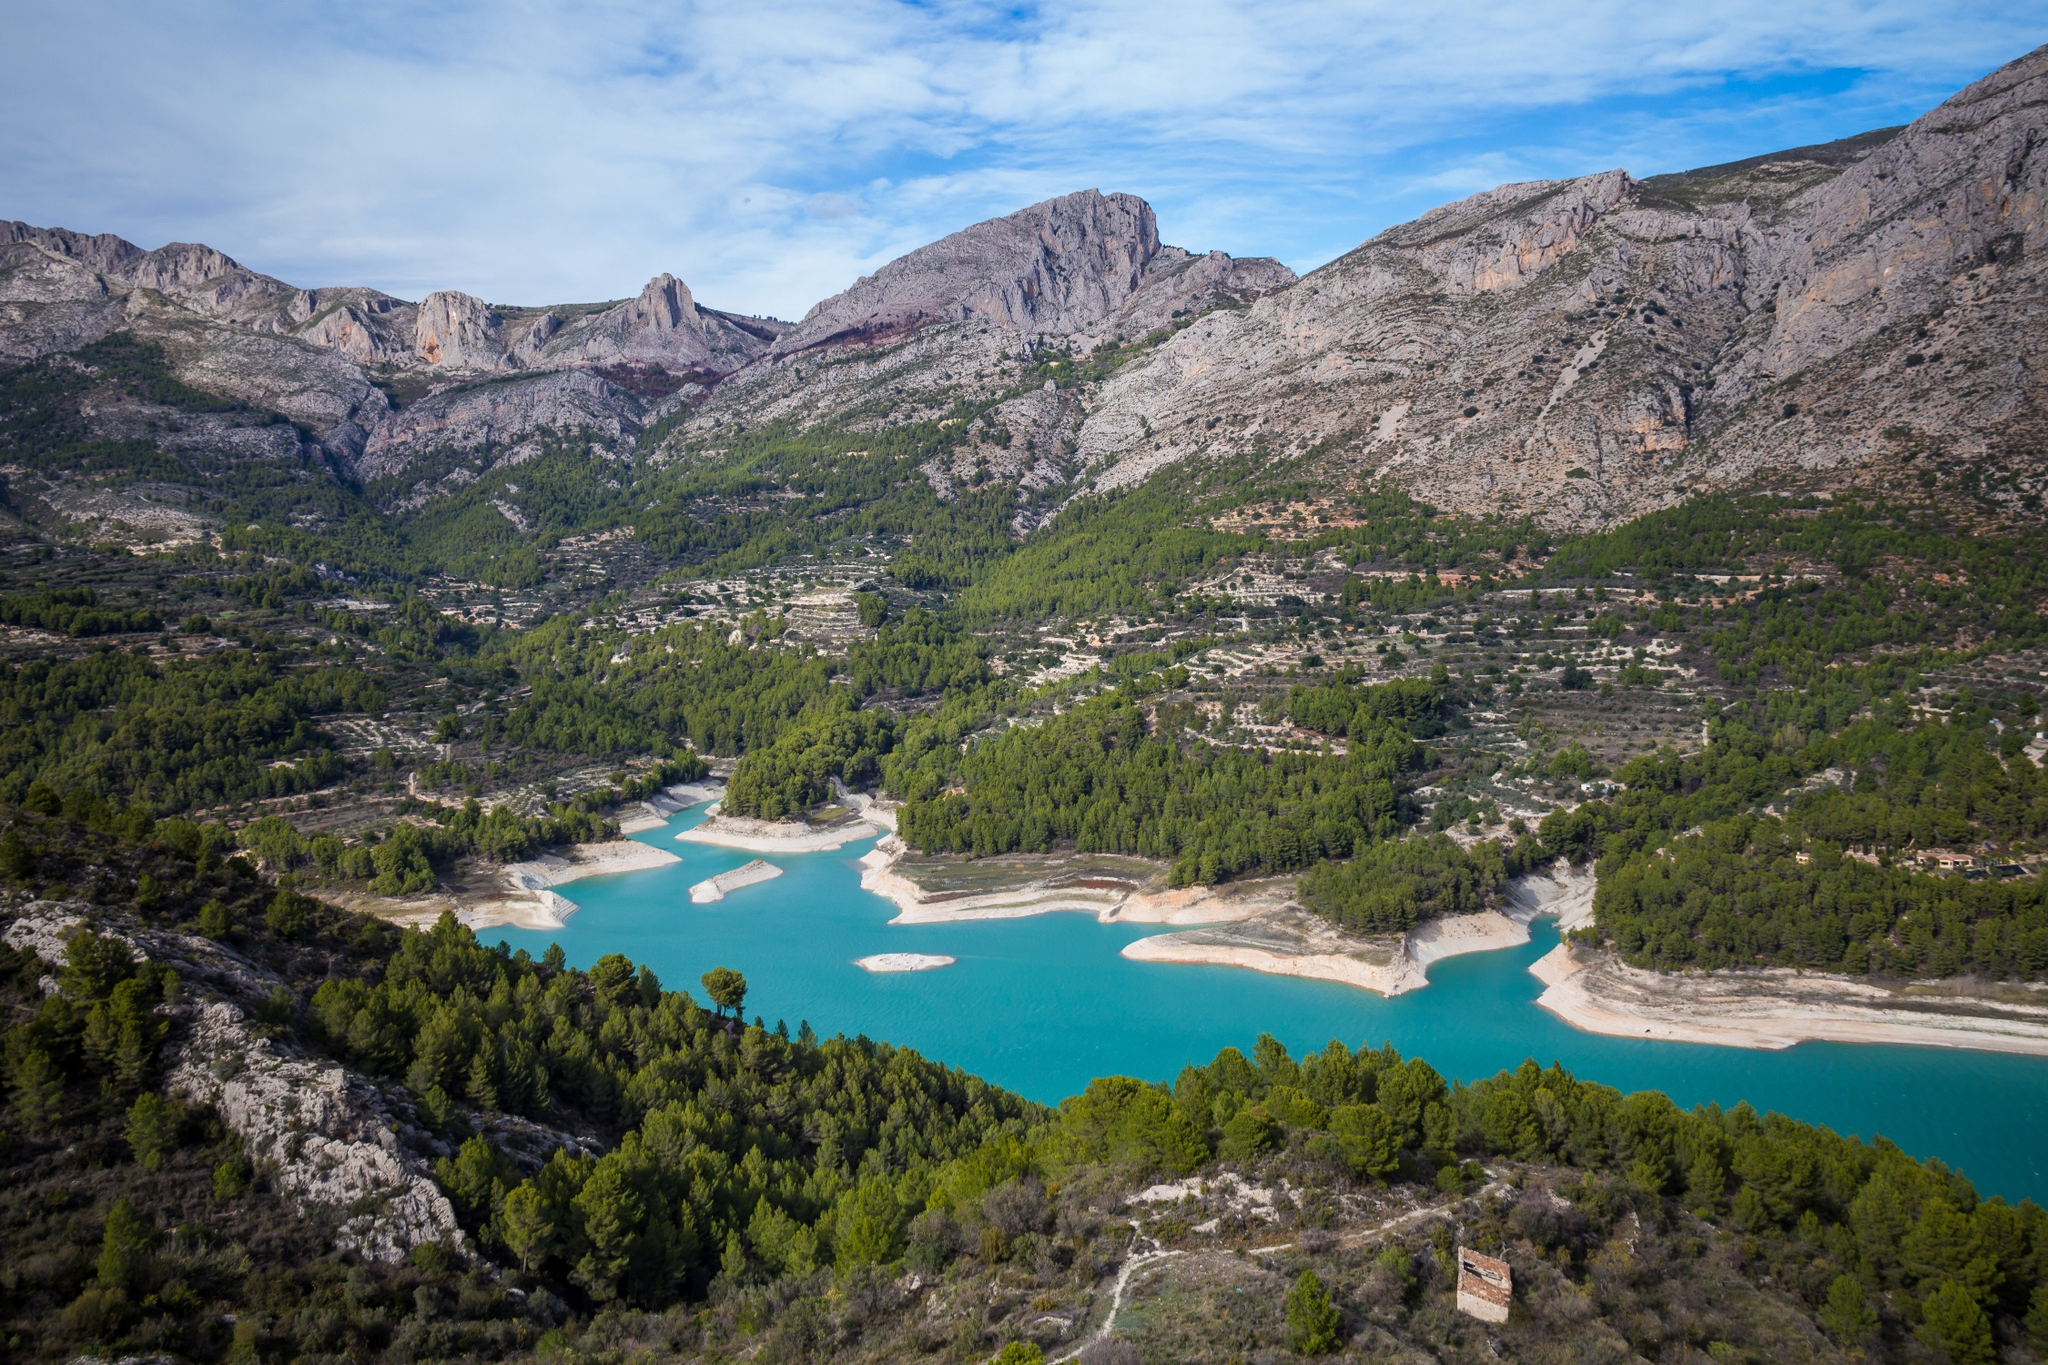What activities might be popular around this reservoir? The Guadalest Reservoir is ideal for various recreational activities. Visitors can enjoy kayaking and canoeing on the water, thanks to its calm surface. Hiking and nature walks are also popular, as the surrounding terrain offers numerous trails that provide panoramic views of the reservoir and the nearby mountain ranges. Additionally, the area is suitable for bird-watching, as it hosts diverse bird species within its rich habitats. 